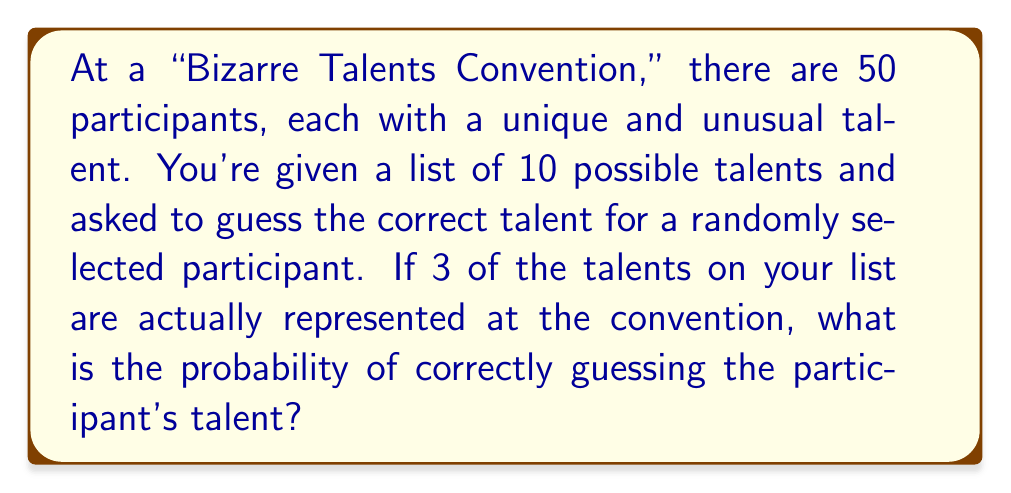Provide a solution to this math problem. Let's approach this step-by-step:

1) First, we need to understand what the question is asking. We're essentially looking for the probability of selecting one of the three correct talents out of the ten options we're given.

2) This is a classic example of a simple probability problem. The probability is calculated by dividing the number of favorable outcomes by the total number of possible outcomes.

3) In this case:
   - Favorable outcomes: 3 (the number of talents on our list that are actually represented)
   - Total possible outcomes: 10 (the total number of talents on our list)

4) Therefore, the probability is:

   $$P(\text{correct guess}) = \frac{\text{favorable outcomes}}{\text{total outcomes}} = \frac{3}{10}$$

5) This can be simplified to:

   $$P(\text{correct guess}) = \frac{3}{10} = 0.3$$

6) We can also express this as a percentage:

   $$P(\text{correct guess}) = 0.3 \times 100\% = 30\%$$

This means you have a 30% chance of correctly guessing the participant's bizarre talent from the list provided.
Answer: $\frac{3}{10}$ or $0.3$ or $30\%$ 